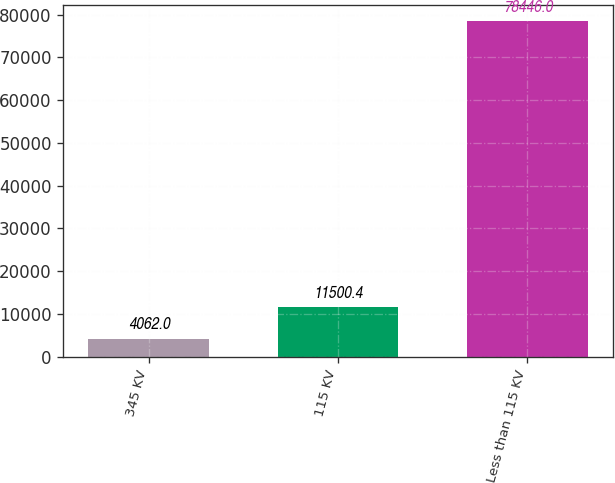Convert chart. <chart><loc_0><loc_0><loc_500><loc_500><bar_chart><fcel>345 KV<fcel>115 KV<fcel>Less than 115 KV<nl><fcel>4062<fcel>11500.4<fcel>78446<nl></chart> 